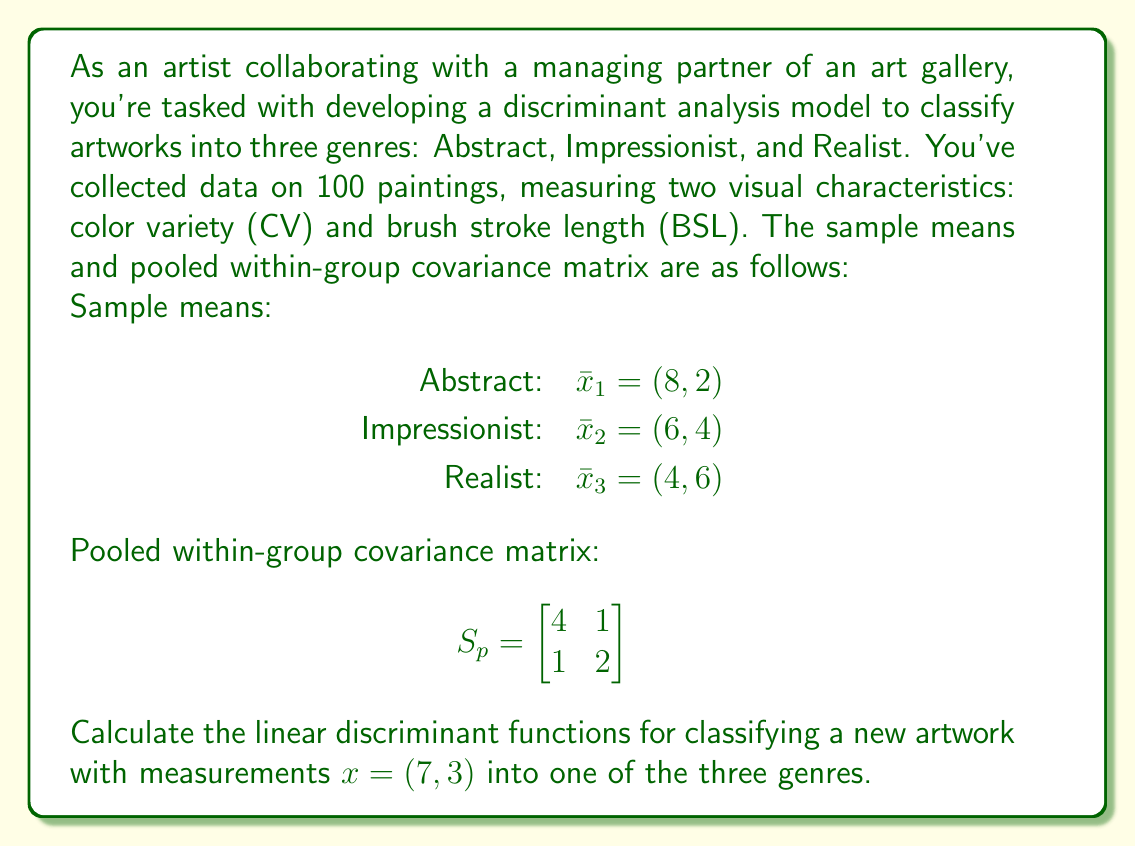Show me your answer to this math problem. To solve this problem, we'll follow these steps:

1) The linear discriminant function for group $i$ is given by:

   $$d_i(x) = x^T S_p^{-1}\bar{x}_i - \frac{1}{2}\bar{x}_i^T S_p^{-1}\bar{x}_i + \ln(p_i)$$

   where $p_i$ is the prior probability of group $i$. Assuming equal prior probabilities, we can ignore the $\ln(p_i)$ term.

2) First, we need to find $S_p^{-1}$:

   $$S_p^{-1} = \frac{1}{4(2) - 1(1)} \begin{bmatrix} 
   2 & -1 \\
   -1 & 4
   \end{bmatrix} = \frac{1}{7} \begin{bmatrix} 
   2 & -1 \\
   -1 & 4
   \end{bmatrix}$$

3) Now, let's calculate $S_p^{-1}\bar{x}_i$ for each group:

   Abstract: $S_p^{-1}\bar{x}_1 = \frac{1}{7} \begin{bmatrix} 
   2 & -1 \\
   -1 & 4
   \end{bmatrix} \begin{bmatrix} 
   8 \\
   2
   \end{bmatrix} = \frac{1}{7} \begin{bmatrix} 
   14 \\
   0
   \end{bmatrix} = \begin{bmatrix} 
   2 \\
   0
   \end{bmatrix}$

   Impressionist: $S_p^{-1}\bar{x}_2 = \frac{1}{7} \begin{bmatrix} 
   2 & -1 \\
   -1 & 4
   \end{bmatrix} \begin{bmatrix} 
   6 \\
   4
   \end{bmatrix} = \frac{1}{7} \begin{bmatrix} 
   8 \\
   10
   \end{bmatrix} = \begin{bmatrix} 
   8/7 \\
   10/7
   \end{bmatrix}$

   Realist: $S_p^{-1}\bar{x}_3 = \frac{1}{7} \begin{bmatrix} 
   2 & -1 \\
   -1 & 4
   \end{bmatrix} \begin{bmatrix} 
   4 \\
   6
   \end{bmatrix} = \frac{1}{7} \begin{bmatrix} 
   2 \\
   20
   \end{bmatrix} = \begin{bmatrix} 
   2/7 \\
   20/7
   \end{bmatrix}$

4) Next, we calculate $\frac{1}{2}\bar{x}_i^T S_p^{-1}\bar{x}_i$ for each group:

   Abstract: $\frac{1}{2}(8, 2) \begin{bmatrix} 
   2 \\
   0
   \end{bmatrix} = 8$

   Impressionist: $\frac{1}{2}(6, 4) \begin{bmatrix} 
   8/7 \\
   10/7
   \end{bmatrix} = 5$

   Realist: $\frac{1}{2}(4, 6) \begin{bmatrix} 
   2/7 \\
   20/7
   \end{bmatrix} = 9$

5) Now we can write the linear discriminant functions:

   Abstract: $d_1(x) = 2x_1 + 0x_2 - 8$
   Impressionist: $d_2(x) = \frac{8}{7}x_1 + \frac{10}{7}x_2 - 5$
   Realist: $d_3(x) = \frac{2}{7}x_1 + \frac{20}{7}x_2 - 9$

6) To classify the new artwork $x = (7, 3)$, we evaluate each discriminant function:

   $d_1(7, 3) = 2(7) + 0(3) - 8 = 6$
   $d_2(7, 3) = \frac{8}{7}(7) + \frac{10}{7}(3) - 5 = 3.29$
   $d_3(7, 3) = \frac{2}{7}(7) + \frac{20}{7}(3) - 9 = -2.43$

The artwork is classified into the group with the highest discriminant function value.
Answer: The linear discriminant functions are:

Abstract: $d_1(x) = 2x_1 + 0x_2 - 8$
Impressionist: $d_2(x) = \frac{8}{7}x_1 + \frac{10}{7}x_2 - 5$
Realist: $d_3(x) = \frac{2}{7}x_1 + \frac{20}{7}x_2 - 9$

For the new artwork $x = (7, 3)$, $d_1(7, 3) = 6$ has the highest value, so it would be classified as Abstract. 